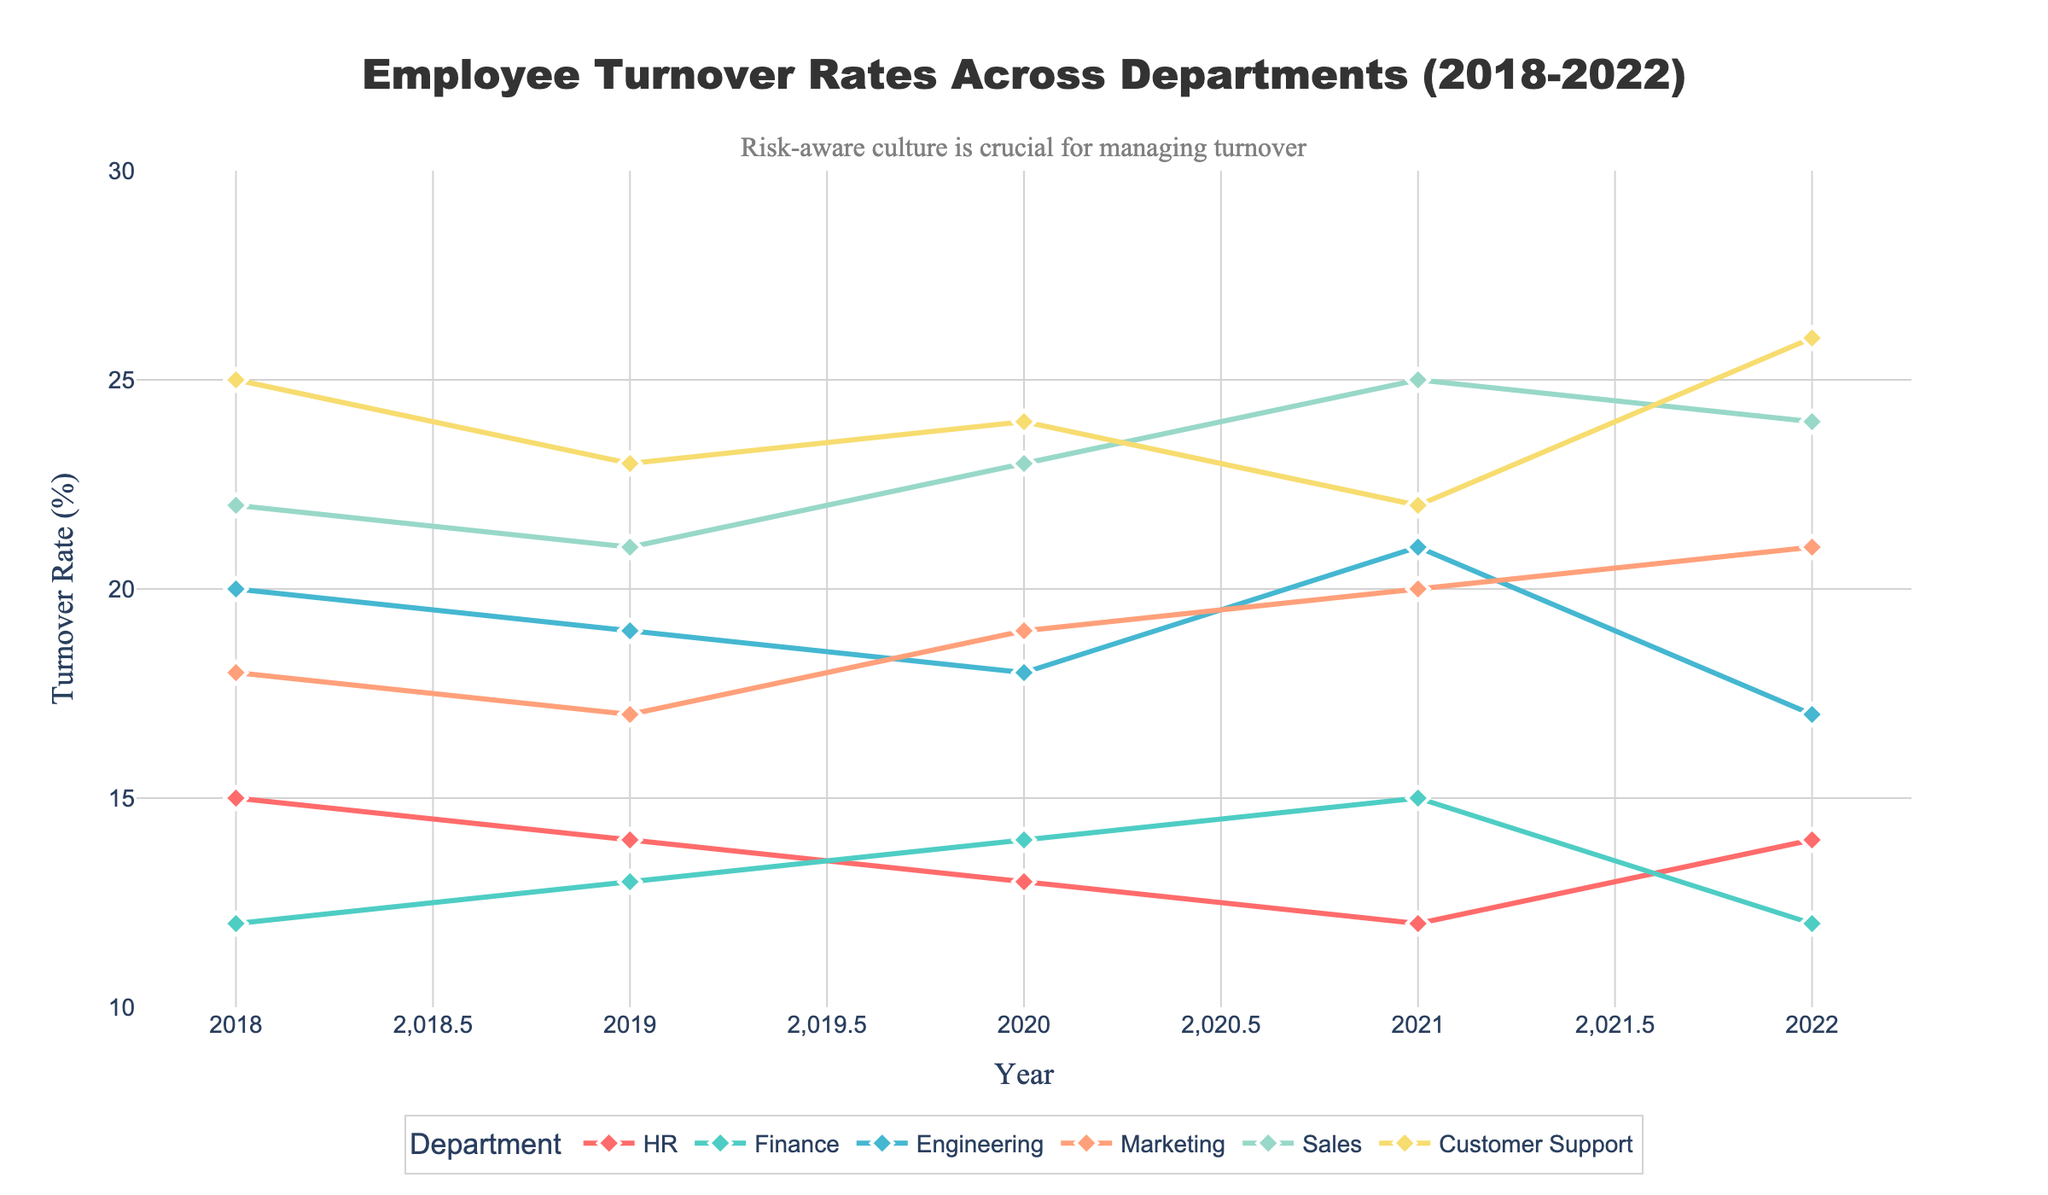What's the title of the figure? The title of the figure is displayed at the top and is meant to summarize the visualized data. In this figure, it is clearly stated.
Answer: Employee Turnover Rates Across Departments (2018-2022) What is the turnover rate for Finance in 2021? To find this, we look at the line corresponding to Finance and locate the data point for the year 2021.
Answer: 15% Which department had the highest turnover rate in 2022? We need to identify the highest data point for the year 2022 across all departments.
Answer: Customer Support What trend can you observe in the turnover rate for Engineering from 2018 to 2022? To determine the trend, follow the Engineering line from 2018 to 2022. Observe if it generally increases, decreases, or remains stable.
Answer: Decreases Between which years did Marketing experience the most significant increase in turnover rate? By comparing the differences in turnover rates year-to-year for Marketing, we identify the largest positive change.
Answer: 2020 to 2021 Which department had the lowest turnover rate in 2020? Locate the data point for each department in 2020 and determine which one is the lowest.
Answer: Engineering How did the turnover rate for HR change from 2018 to 2022? Check the turnover rate for HR in 2018 and in 2022, then compare to see if it increased, decreased, or stayed the same.
Answer: Decreased What was the average turnover rate for Sales over the five years? Add the turnover rates for Sales from 2018 to 2022 and divide by the number of years. (22 + 21 + 23 + 25 + 24) / 5 = 23
Answer: 23% Which department saw an increasing trend in turnover rate every year from 2018 to 2021 but a decrease in 2022? Identify the department with yearly increasing rates from 2018 to 2021 and then check if it decreased in 2022.
Answer: Customer Support Which department had identical turnover rates in both 2018 and 2022? Look for departments where the turnover rates in 2018 and 2022 match exactly.
Answer: Finance 